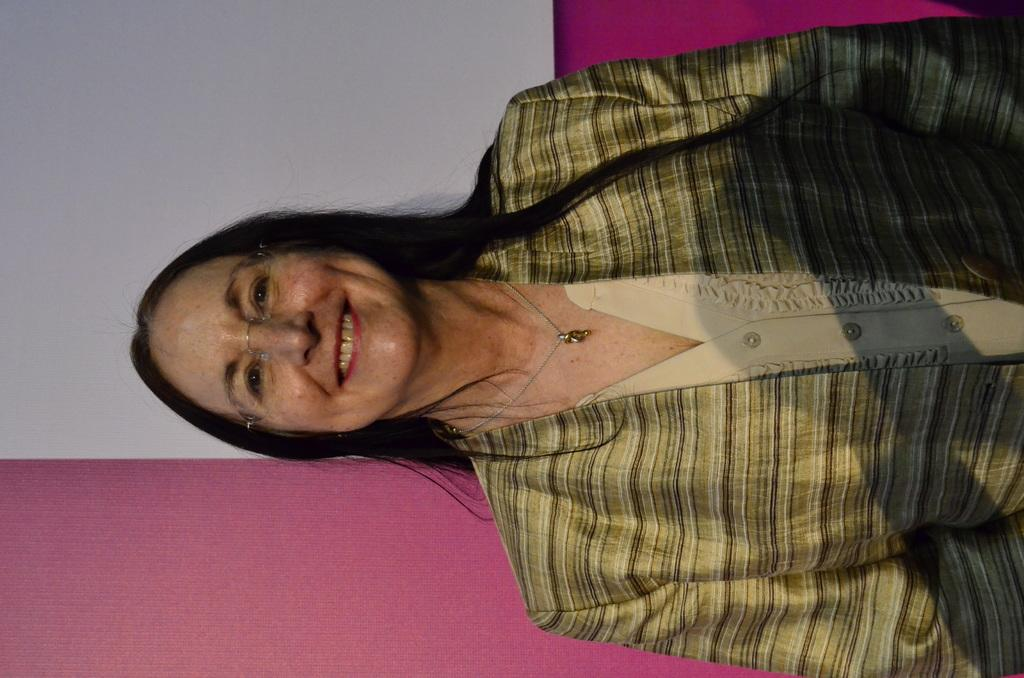What is the primary subject of the image? There is a woman in the image. What is the woman's facial expression? The woman is smiling. Can you describe the background of the image? There is a wall in the background of the image. What type of stew is the woman cooking in the image? There is no stew present in the image; it only features a woman who is smiling. What is the woman's position relative to the edge of the image? The image does not provide information about the woman's position relative to the edge of the image. 